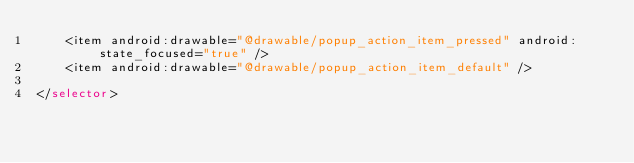<code> <loc_0><loc_0><loc_500><loc_500><_XML_>    <item android:drawable="@drawable/popup_action_item_pressed" android:state_focused="true" />
    <item android:drawable="@drawable/popup_action_item_default" />

</selector></code> 